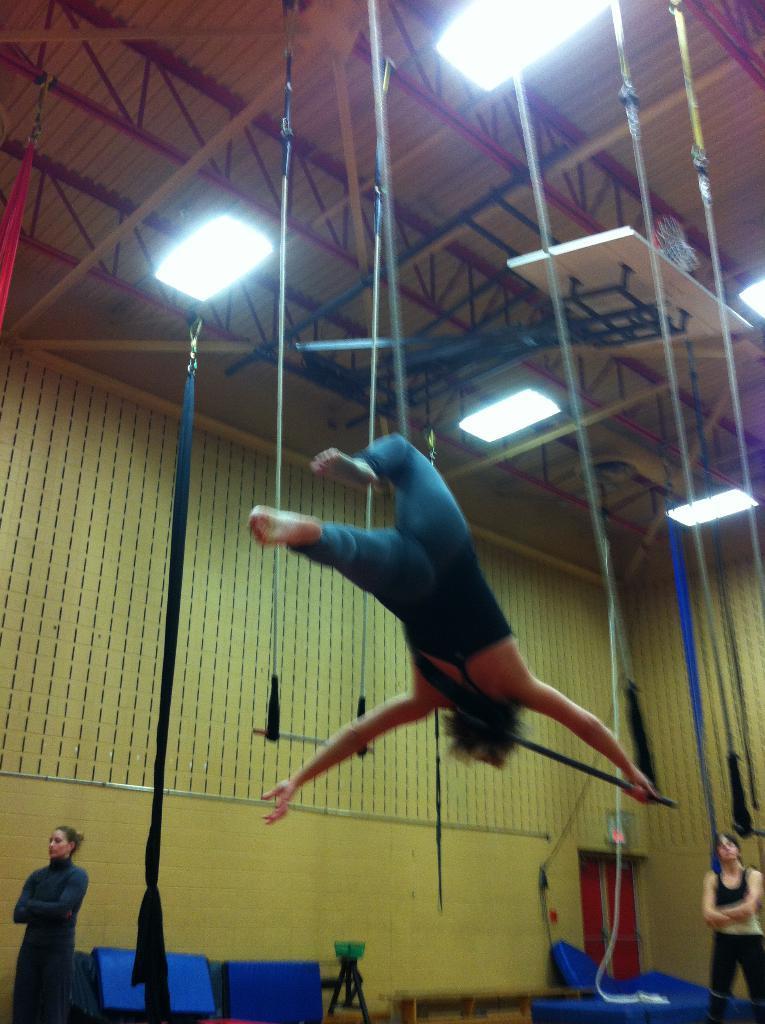Describe this image in one or two sentences. In this image there are two ladies standing on a floor, in the background there is a wall, at the top there is a lady performing gymnastics with ropes and there are lights. 